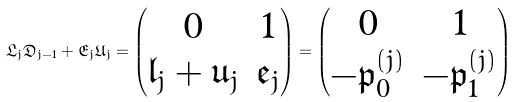Convert formula to latex. <formula><loc_0><loc_0><loc_500><loc_500>\mathfrak { L } _ { j } \mathfrak { D } _ { j - 1 } + \mathfrak { E } _ { j } \mathfrak { U } _ { j } = \begin{pmatrix} 0 & 1 \\ { \mathfrak l } _ { j } + { \mathfrak u } _ { j } & { \mathfrak e } _ { j } \\ \end{pmatrix} = \begin{pmatrix} 0 & 1 \\ - { \mathfrak p } _ { 0 } ^ { ( j ) } & - { \mathfrak p } _ { 1 } ^ { ( j ) } \end{pmatrix}</formula> 